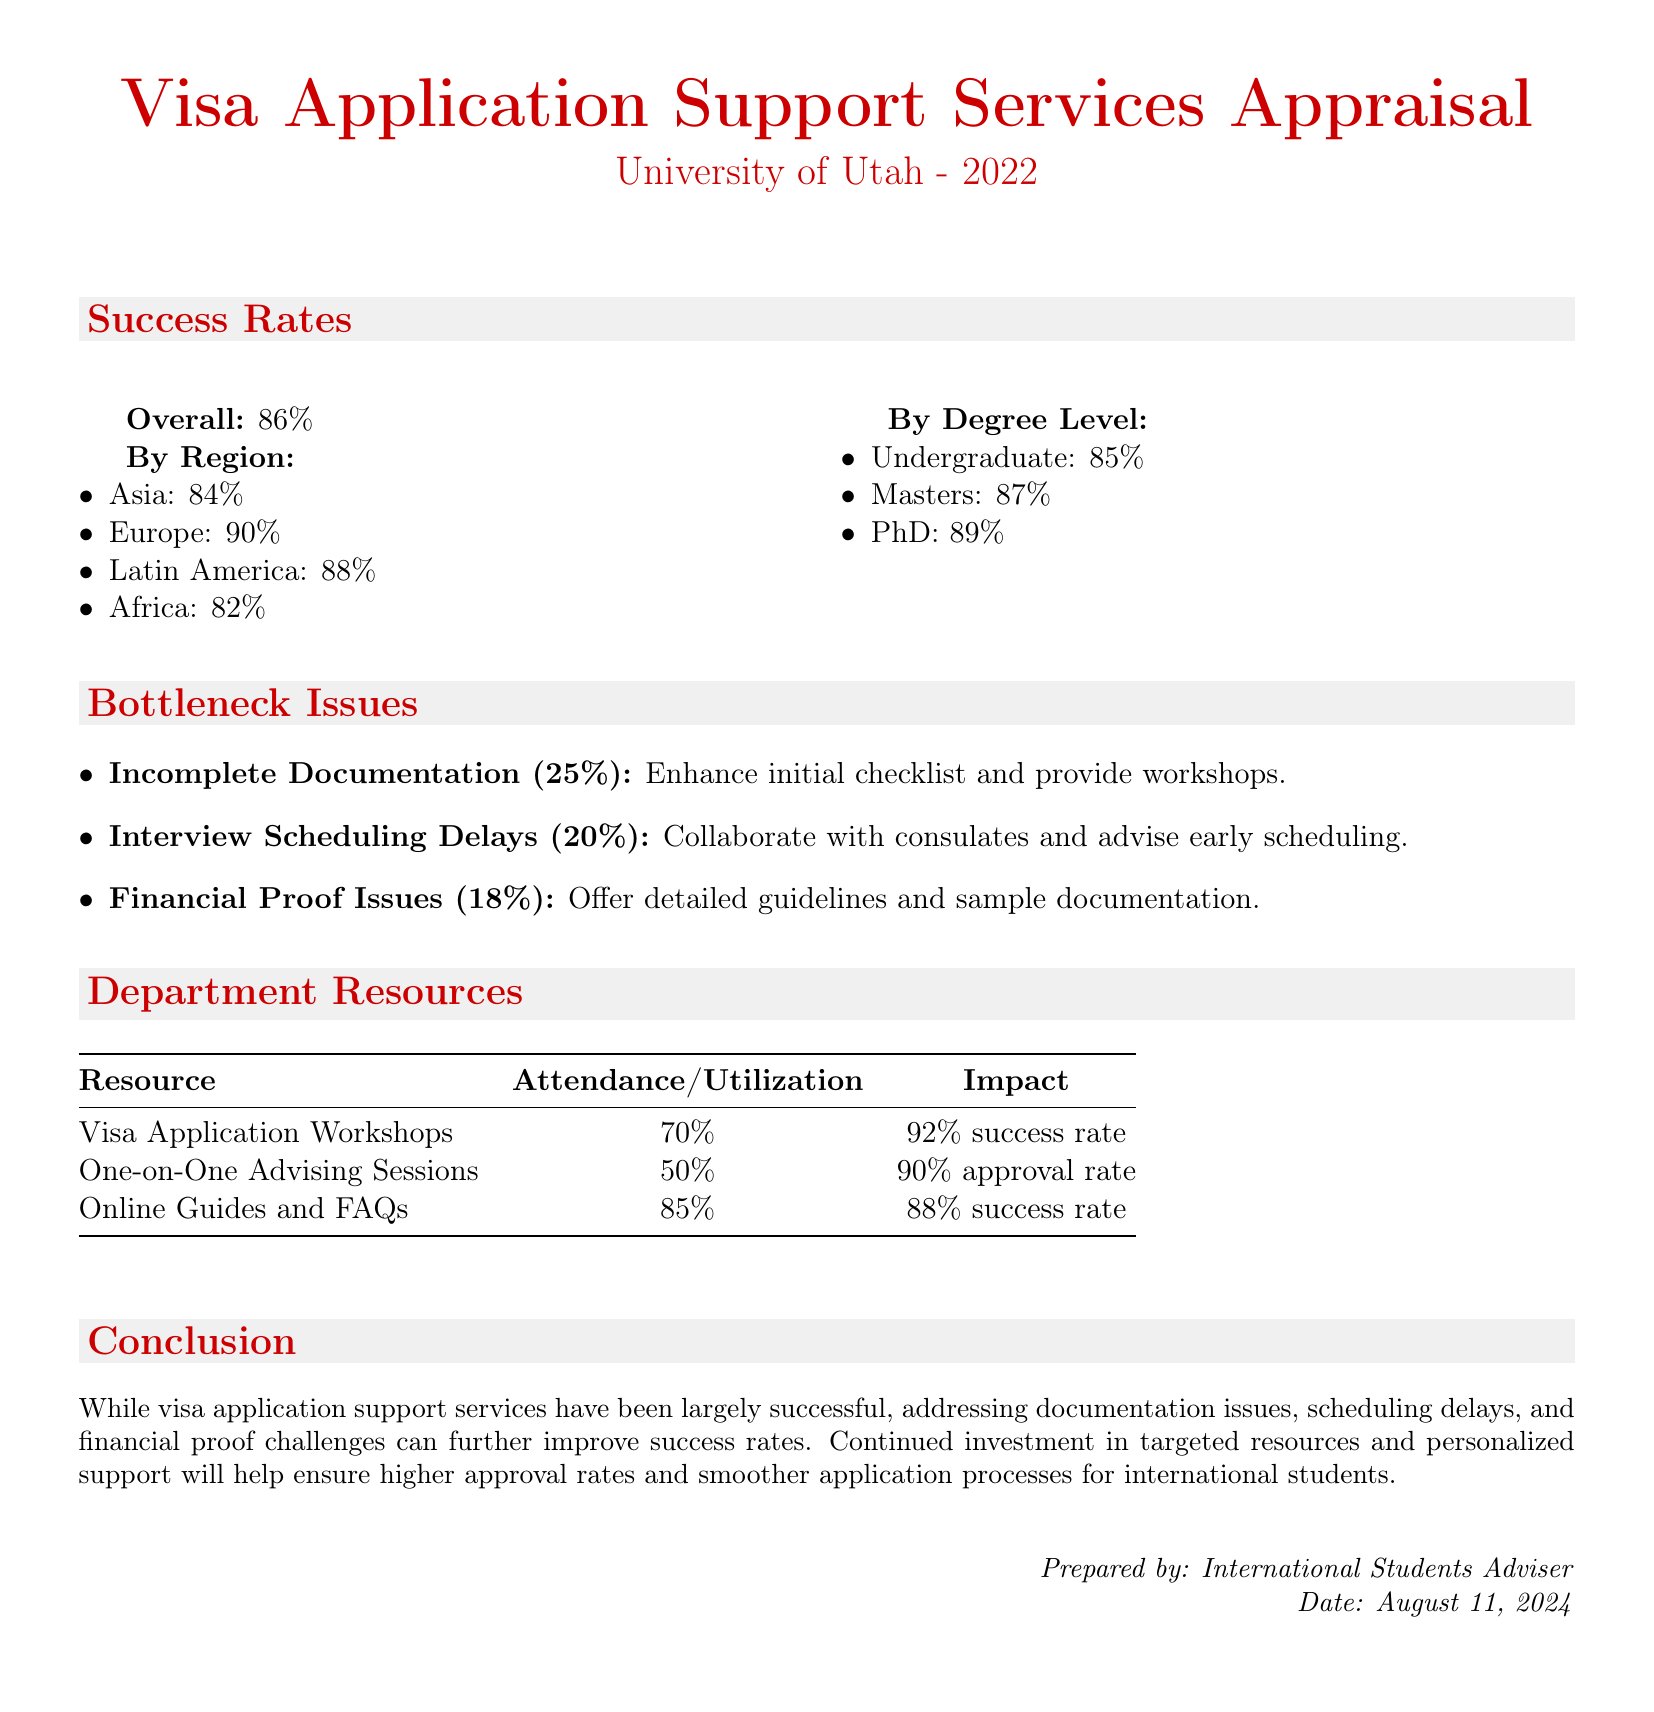What is the overall success rate of visa applications? The overall success rate is provided in the "Success Rates" section of the document.
Answer: 86% What is the success rate for applicants from Africa? The success rate for Africa is mentioned under the "By Region" in the document.
Answer: 82% What percentage of bottleneck issues is due to incomplete documentation? This percentage is outlined in the "Bottleneck Issues" section.
Answer: 25% What was the attendance/utilization rate of Visa Application Workshops? The attendance/utilization of workshops is noted in the "Department Resources" section.
Answer: 70% Which degree level has the highest success rate? The success rates by degree level are detailed, and this is the one with the highest percentage.
Answer: PhD What is the impact of online guides and FAQs on success rates? The impact is specified in the "Department Resources" section of the document.
Answer: 88% success rate What is the main suggested improvement for interview scheduling? This suggestion is found in the "Bottleneck Issues" section, providing insight on how to address the issue.
Answer: Collaborate with consulates What is the success rate for Masters applicants? The success rate by degree level specifically states this percentage in the document.
Answer: 87% 